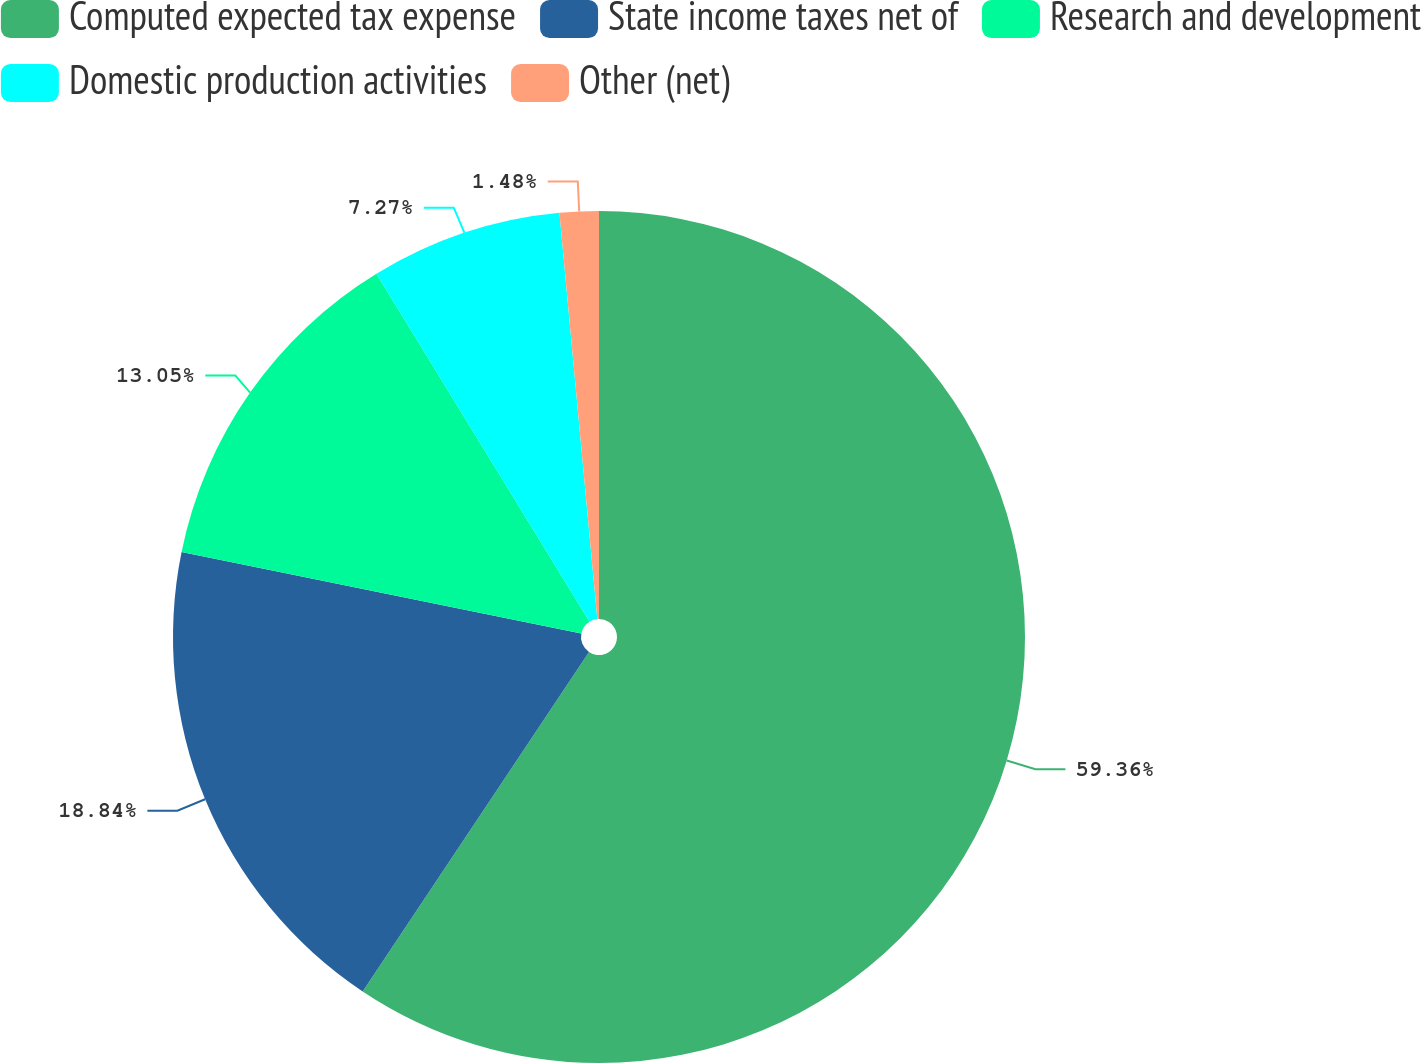Convert chart. <chart><loc_0><loc_0><loc_500><loc_500><pie_chart><fcel>Computed expected tax expense<fcel>State income taxes net of<fcel>Research and development<fcel>Domestic production activities<fcel>Other (net)<nl><fcel>59.36%<fcel>18.84%<fcel>13.05%<fcel>7.27%<fcel>1.48%<nl></chart> 